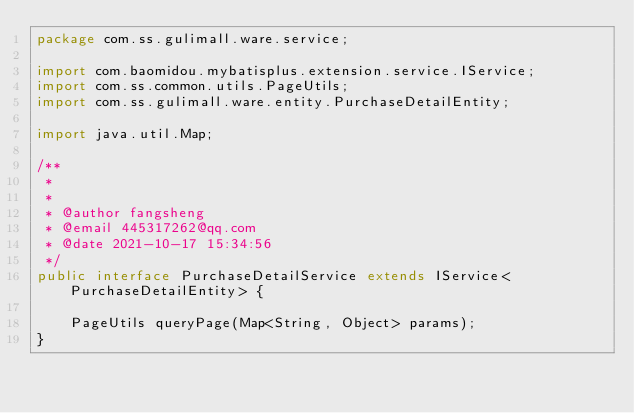Convert code to text. <code><loc_0><loc_0><loc_500><loc_500><_Java_>package com.ss.gulimall.ware.service;

import com.baomidou.mybatisplus.extension.service.IService;
import com.ss.common.utils.PageUtils;
import com.ss.gulimall.ware.entity.PurchaseDetailEntity;

import java.util.Map;

/**
 * 
 *
 * @author fangsheng
 * @email 445317262@qq.com
 * @date 2021-10-17 15:34:56
 */
public interface PurchaseDetailService extends IService<PurchaseDetailEntity> {

    PageUtils queryPage(Map<String, Object> params);
}

</code> 